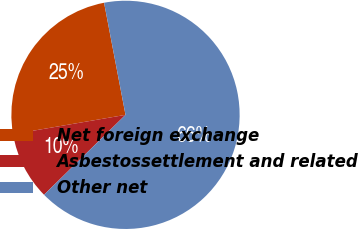<chart> <loc_0><loc_0><loc_500><loc_500><pie_chart><fcel>Net foreign exchange<fcel>Asbestossettlement and related<fcel>Other net<nl><fcel>24.7%<fcel>9.64%<fcel>65.66%<nl></chart> 